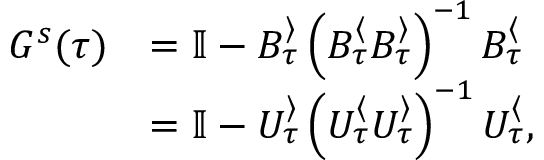Convert formula to latex. <formula><loc_0><loc_0><loc_500><loc_500>\begin{array} { r l } { G ^ { s } ( \tau ) } & { = \mathbb { I } - B _ { \tau } ^ { \rangle } \left ( B _ { \tau } ^ { \langle } B _ { \tau } ^ { \rangle } \right ) ^ { - 1 } B _ { \tau } ^ { \langle } } \\ & { = \mathbb { I } - U _ { \tau } ^ { \rangle } \left ( U _ { \tau } ^ { \langle } U _ { \tau } ^ { \rangle } \right ) ^ { - 1 } U _ { \tau } ^ { \langle } , } \end{array}</formula> 